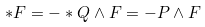<formula> <loc_0><loc_0><loc_500><loc_500>* F = - \ast Q \wedge F = - P \wedge F</formula> 